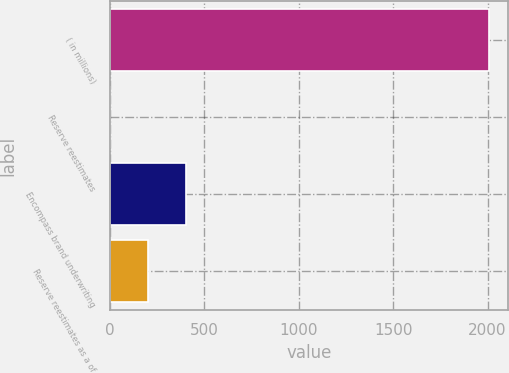Convert chart. <chart><loc_0><loc_0><loc_500><loc_500><bar_chart><fcel>( in millions)<fcel>Reserve reestimates<fcel>Encompass brand underwriting<fcel>Reserve reestimates as a of<nl><fcel>2008<fcel>3<fcel>404<fcel>203.5<nl></chart> 